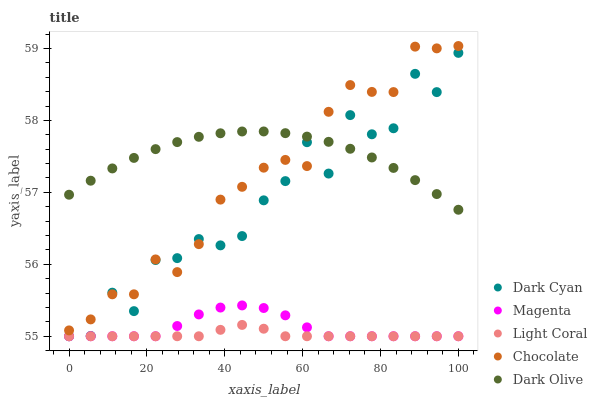Does Light Coral have the minimum area under the curve?
Answer yes or no. Yes. Does Dark Olive have the maximum area under the curve?
Answer yes or no. Yes. Does Magenta have the minimum area under the curve?
Answer yes or no. No. Does Magenta have the maximum area under the curve?
Answer yes or no. No. Is Light Coral the smoothest?
Answer yes or no. Yes. Is Dark Cyan the roughest?
Answer yes or no. Yes. Is Magenta the smoothest?
Answer yes or no. No. Is Magenta the roughest?
Answer yes or no. No. Does Dark Cyan have the lowest value?
Answer yes or no. Yes. Does Dark Olive have the lowest value?
Answer yes or no. No. Does Chocolate have the highest value?
Answer yes or no. Yes. Does Magenta have the highest value?
Answer yes or no. No. Is Magenta less than Dark Olive?
Answer yes or no. Yes. Is Dark Olive greater than Magenta?
Answer yes or no. Yes. Does Chocolate intersect Dark Cyan?
Answer yes or no. Yes. Is Chocolate less than Dark Cyan?
Answer yes or no. No. Is Chocolate greater than Dark Cyan?
Answer yes or no. No. Does Magenta intersect Dark Olive?
Answer yes or no. No. 